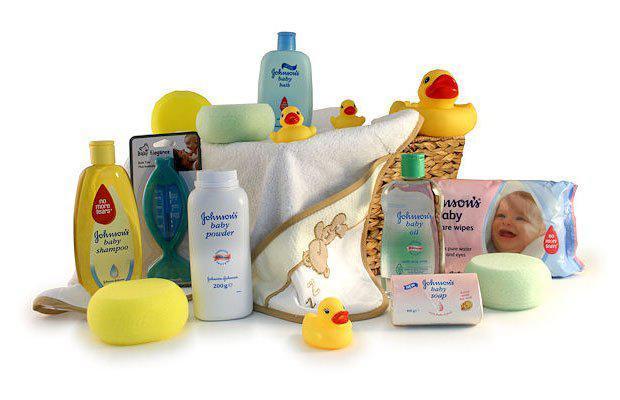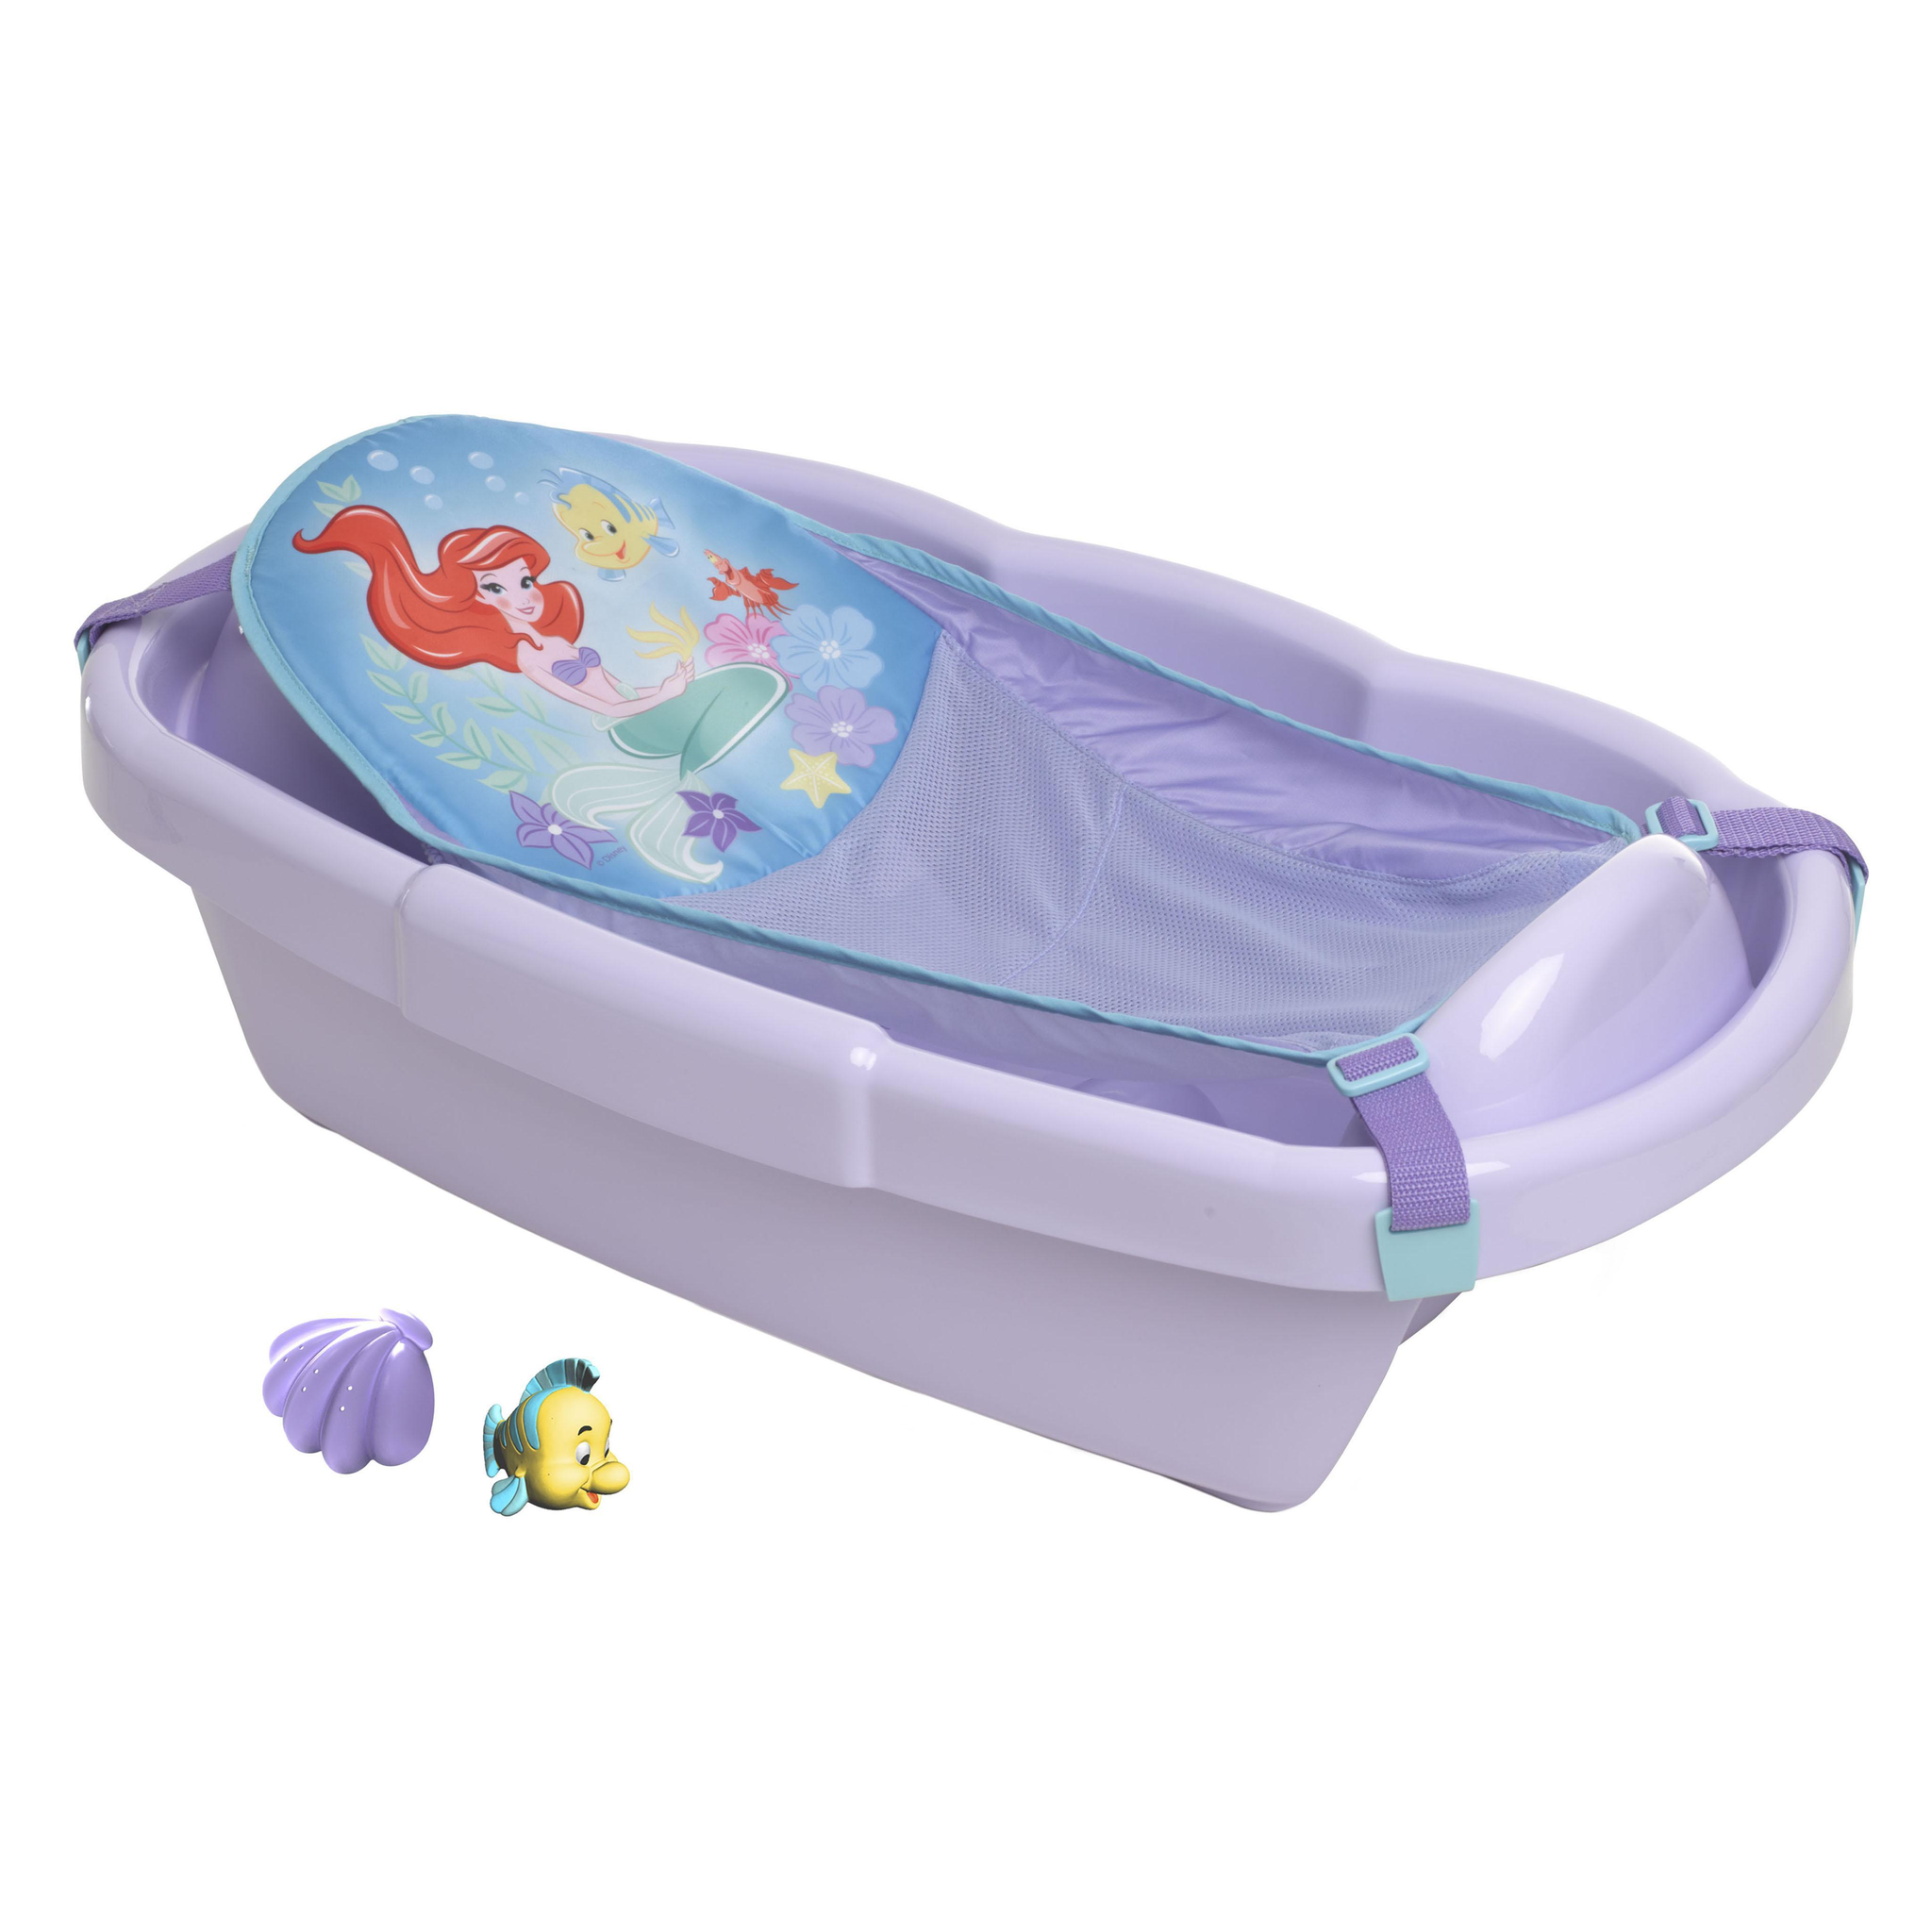The first image is the image on the left, the second image is the image on the right. Examine the images to the left and right. Is the description "Each image includes at least one row of folded cloth items, and one image features a package of eight rolled towels." accurate? Answer yes or no. No. The first image is the image on the left, the second image is the image on the right. For the images shown, is this caption "There are exactly eight rolled towels." true? Answer yes or no. No. 